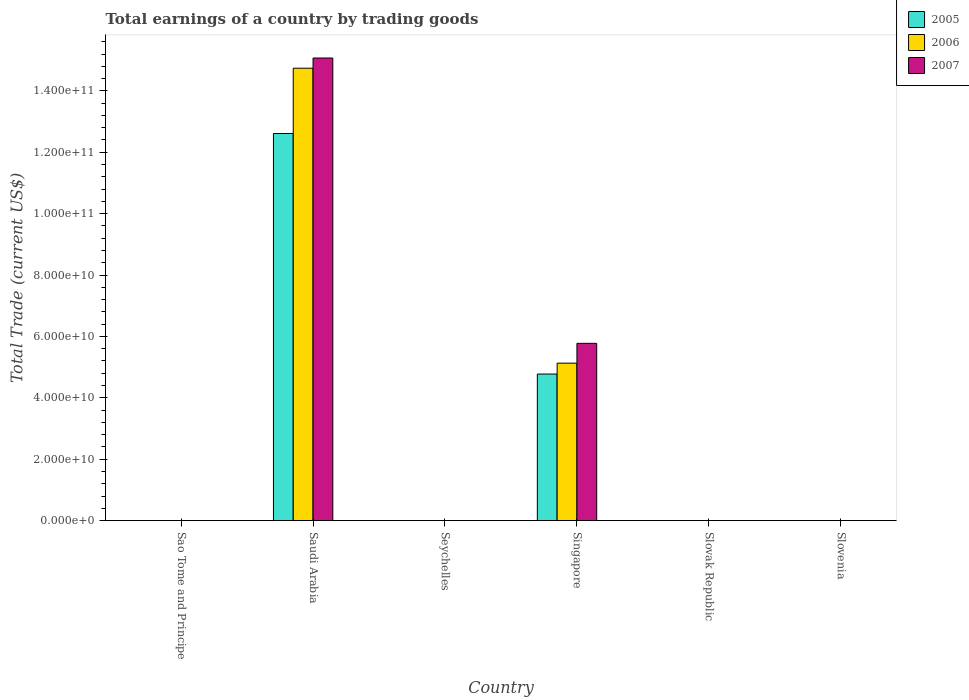Are the number of bars on each tick of the X-axis equal?
Keep it short and to the point. No. How many bars are there on the 5th tick from the right?
Make the answer very short. 3. What is the label of the 3rd group of bars from the left?
Make the answer very short. Seychelles. Across all countries, what is the maximum total earnings in 2005?
Your answer should be compact. 1.26e+11. In which country was the total earnings in 2006 maximum?
Offer a terse response. Saudi Arabia. What is the total total earnings in 2006 in the graph?
Keep it short and to the point. 1.99e+11. What is the difference between the total earnings in 2006 in Saudi Arabia and that in Singapore?
Offer a very short reply. 9.61e+1. What is the difference between the total earnings in 2005 in Saudi Arabia and the total earnings in 2007 in Singapore?
Make the answer very short. 6.84e+1. What is the average total earnings in 2005 per country?
Keep it short and to the point. 2.90e+1. What is the difference between the total earnings of/in 2006 and total earnings of/in 2007 in Saudi Arabia?
Your answer should be compact. -3.32e+09. Is the total earnings in 2007 in Saudi Arabia less than that in Singapore?
Your response must be concise. No. What is the difference between the highest and the lowest total earnings in 2007?
Your answer should be compact. 1.51e+11. In how many countries, is the total earnings in 2005 greater than the average total earnings in 2005 taken over all countries?
Make the answer very short. 2. Is it the case that in every country, the sum of the total earnings in 2007 and total earnings in 2005 is greater than the total earnings in 2006?
Provide a succinct answer. No. Are all the bars in the graph horizontal?
Ensure brevity in your answer.  No. What is the difference between two consecutive major ticks on the Y-axis?
Ensure brevity in your answer.  2.00e+1. Are the values on the major ticks of Y-axis written in scientific E-notation?
Your answer should be compact. Yes. Does the graph contain grids?
Provide a short and direct response. No. Where does the legend appear in the graph?
Provide a succinct answer. Top right. How are the legend labels stacked?
Your response must be concise. Vertical. What is the title of the graph?
Offer a very short reply. Total earnings of a country by trading goods. Does "2002" appear as one of the legend labels in the graph?
Make the answer very short. No. What is the label or title of the Y-axis?
Make the answer very short. Total Trade (current US$). What is the Total Trade (current US$) in 2006 in Sao Tome and Principe?
Provide a succinct answer. 0. What is the Total Trade (current US$) in 2005 in Saudi Arabia?
Your answer should be very brief. 1.26e+11. What is the Total Trade (current US$) of 2006 in Saudi Arabia?
Offer a terse response. 1.47e+11. What is the Total Trade (current US$) in 2007 in Saudi Arabia?
Give a very brief answer. 1.51e+11. What is the Total Trade (current US$) of 2006 in Seychelles?
Provide a short and direct response. 0. What is the Total Trade (current US$) of 2007 in Seychelles?
Keep it short and to the point. 0. What is the Total Trade (current US$) of 2005 in Singapore?
Make the answer very short. 4.77e+1. What is the Total Trade (current US$) of 2006 in Singapore?
Keep it short and to the point. 5.13e+1. What is the Total Trade (current US$) in 2007 in Singapore?
Offer a very short reply. 5.77e+1. What is the Total Trade (current US$) in 2005 in Slovak Republic?
Your answer should be very brief. 0. What is the Total Trade (current US$) of 2005 in Slovenia?
Offer a very short reply. 0. Across all countries, what is the maximum Total Trade (current US$) of 2005?
Your answer should be compact. 1.26e+11. Across all countries, what is the maximum Total Trade (current US$) in 2006?
Your answer should be very brief. 1.47e+11. Across all countries, what is the maximum Total Trade (current US$) of 2007?
Provide a short and direct response. 1.51e+11. Across all countries, what is the minimum Total Trade (current US$) in 2006?
Provide a short and direct response. 0. Across all countries, what is the minimum Total Trade (current US$) of 2007?
Offer a very short reply. 0. What is the total Total Trade (current US$) of 2005 in the graph?
Offer a very short reply. 1.74e+11. What is the total Total Trade (current US$) in 2006 in the graph?
Ensure brevity in your answer.  1.99e+11. What is the total Total Trade (current US$) of 2007 in the graph?
Your answer should be very brief. 2.08e+11. What is the difference between the Total Trade (current US$) of 2005 in Saudi Arabia and that in Singapore?
Provide a short and direct response. 7.84e+1. What is the difference between the Total Trade (current US$) of 2006 in Saudi Arabia and that in Singapore?
Your answer should be very brief. 9.61e+1. What is the difference between the Total Trade (current US$) of 2007 in Saudi Arabia and that in Singapore?
Ensure brevity in your answer.  9.30e+1. What is the difference between the Total Trade (current US$) of 2005 in Saudi Arabia and the Total Trade (current US$) of 2006 in Singapore?
Offer a terse response. 7.48e+1. What is the difference between the Total Trade (current US$) of 2005 in Saudi Arabia and the Total Trade (current US$) of 2007 in Singapore?
Ensure brevity in your answer.  6.84e+1. What is the difference between the Total Trade (current US$) in 2006 in Saudi Arabia and the Total Trade (current US$) in 2007 in Singapore?
Ensure brevity in your answer.  8.96e+1. What is the average Total Trade (current US$) of 2005 per country?
Provide a short and direct response. 2.90e+1. What is the average Total Trade (current US$) in 2006 per country?
Give a very brief answer. 3.31e+1. What is the average Total Trade (current US$) of 2007 per country?
Keep it short and to the point. 3.47e+1. What is the difference between the Total Trade (current US$) of 2005 and Total Trade (current US$) of 2006 in Saudi Arabia?
Offer a terse response. -2.13e+1. What is the difference between the Total Trade (current US$) of 2005 and Total Trade (current US$) of 2007 in Saudi Arabia?
Keep it short and to the point. -2.46e+1. What is the difference between the Total Trade (current US$) of 2006 and Total Trade (current US$) of 2007 in Saudi Arabia?
Give a very brief answer. -3.32e+09. What is the difference between the Total Trade (current US$) in 2005 and Total Trade (current US$) in 2006 in Singapore?
Offer a terse response. -3.55e+09. What is the difference between the Total Trade (current US$) in 2005 and Total Trade (current US$) in 2007 in Singapore?
Keep it short and to the point. -1.00e+1. What is the difference between the Total Trade (current US$) in 2006 and Total Trade (current US$) in 2007 in Singapore?
Your answer should be very brief. -6.46e+09. What is the ratio of the Total Trade (current US$) in 2005 in Saudi Arabia to that in Singapore?
Offer a very short reply. 2.64. What is the ratio of the Total Trade (current US$) in 2006 in Saudi Arabia to that in Singapore?
Offer a very short reply. 2.87. What is the ratio of the Total Trade (current US$) in 2007 in Saudi Arabia to that in Singapore?
Provide a succinct answer. 2.61. What is the difference between the highest and the lowest Total Trade (current US$) of 2005?
Ensure brevity in your answer.  1.26e+11. What is the difference between the highest and the lowest Total Trade (current US$) of 2006?
Keep it short and to the point. 1.47e+11. What is the difference between the highest and the lowest Total Trade (current US$) of 2007?
Your answer should be very brief. 1.51e+11. 